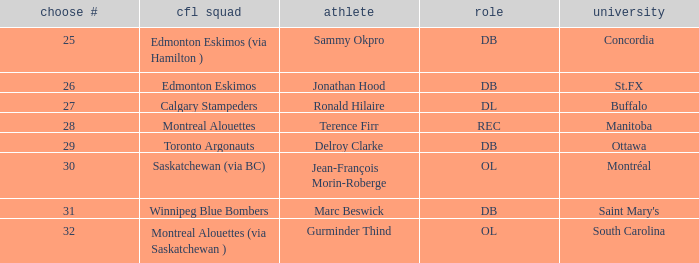Which College has a Pick # larger than 30, and a Position of ol? South Carolina. 